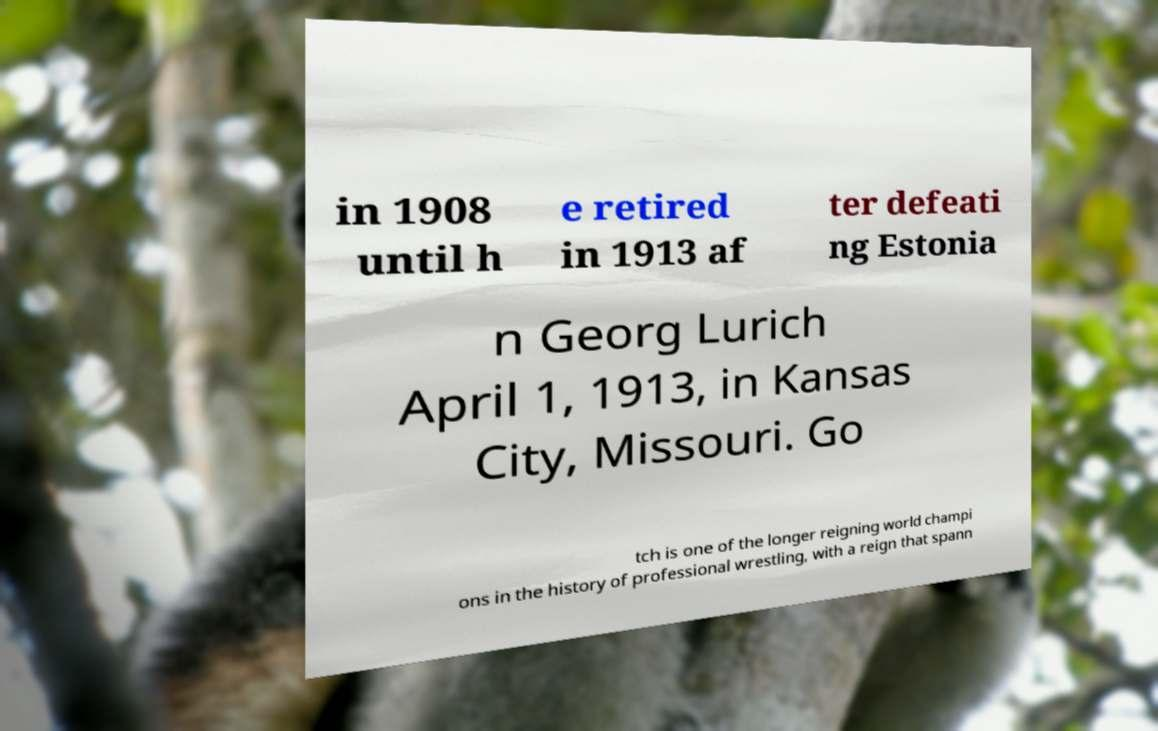For documentation purposes, I need the text within this image transcribed. Could you provide that? in 1908 until h e retired in 1913 af ter defeati ng Estonia n Georg Lurich April 1, 1913, in Kansas City, Missouri. Go tch is one of the longer reigning world champi ons in the history of professional wrestling, with a reign that spann 